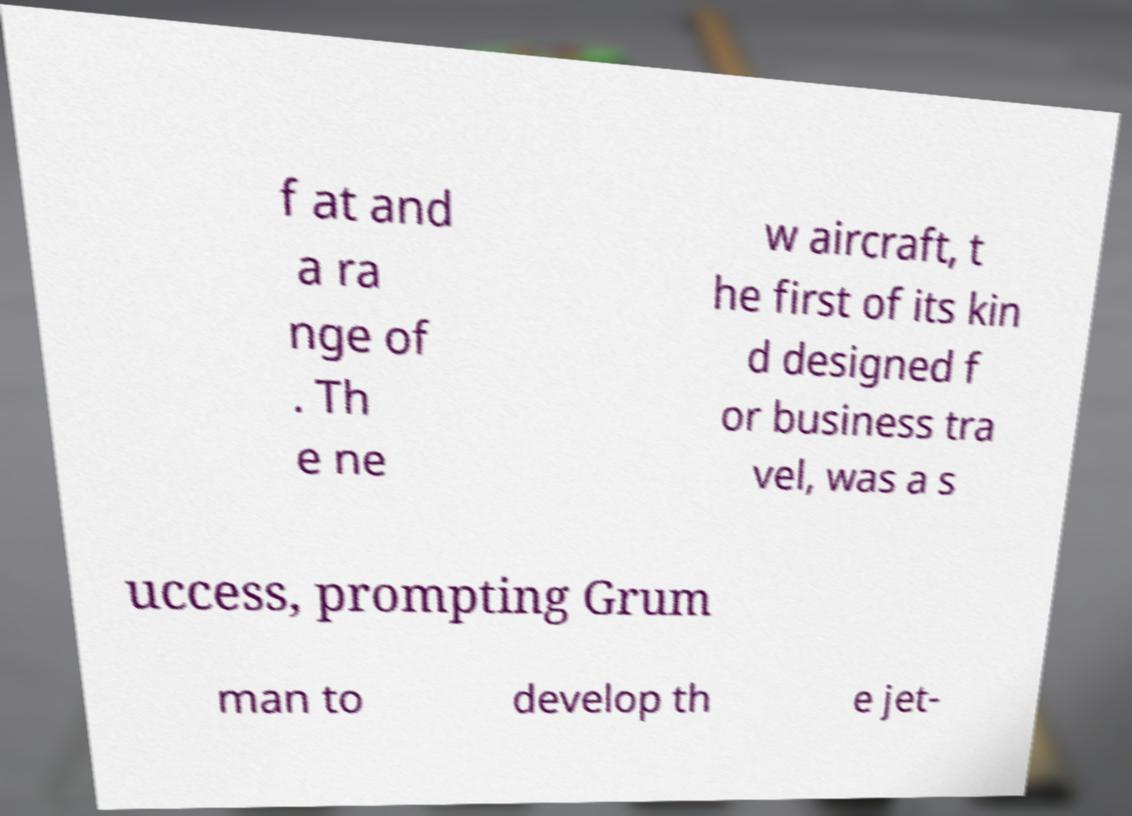Can you read and provide the text displayed in the image?This photo seems to have some interesting text. Can you extract and type it out for me? f at and a ra nge of . Th e ne w aircraft, t he first of its kin d designed f or business tra vel, was a s uccess, prompting Grum man to develop th e jet- 